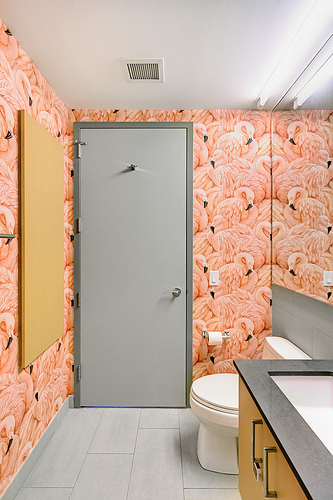<image>
Is there a toilet behind the sink? Yes. From this viewpoint, the toilet is positioned behind the sink, with the sink partially or fully occluding the toilet. Is there a toilet to the right of the toilet paper? Yes. From this viewpoint, the toilet is positioned to the right side relative to the toilet paper. 